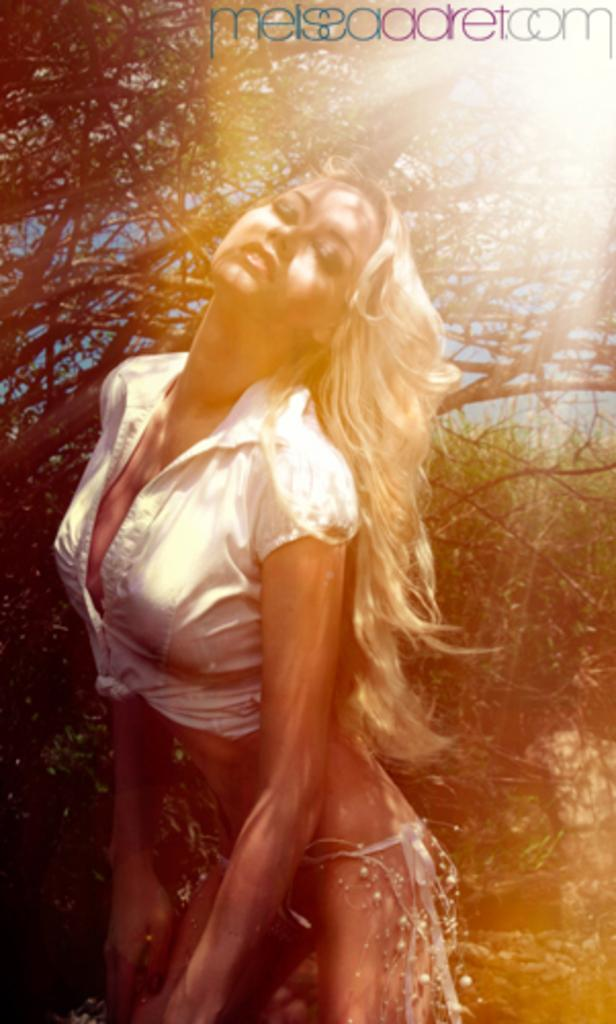Who is present in the image? There is a woman in the image. What can be seen in the background of the image? There are plants in the background of the image. Is there any text or logo visible in the image? Yes, there is a watermark at the top of the image. What type of coal is being used to create patterns on the cloth in the image? There is no coal or cloth present in the image, and therefore no such activity can be observed. 